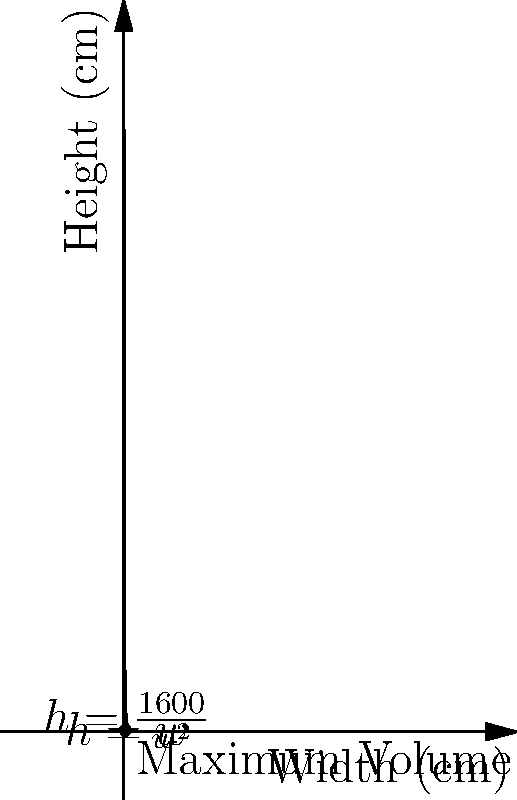As a small business owner, you want to design a new product package that maximizes volume while minimizing material costs. The package is a rectangular prism with a square base. The total surface area of the package must be 1600 cm². What dimensions should you choose to maximize the volume of the package? Let's approach this step-by-step:

1) Let $w$ be the width of the square base and $h$ be the height of the prism.

2) The surface area of the prism is given by:
   $SA = 2w^2 + 4wh = 1600$

3) Solving for $h$:
   $h = \frac{1600 - 2w^2}{4w} = \frac{800}{2w} - \frac{w}{2} = \frac{1600 - w^3}{4w}$

4) The volume of the prism is:
   $V = w^2h = w^2(\frac{1600 - w^3}{4w}) = \frac{1600w - w^4}{4}$

5) To find the maximum volume, we differentiate $V$ with respect to $w$ and set it to zero:
   $\frac{dV}{dw} = \frac{1600 - 4w^3}{4} = 0$

6) Solving this equation:
   $1600 - 4w^3 = 0$
   $4w^3 = 1600$
   $w^3 = 400$
   $w = \sqrt[3]{400} = 4\sqrt[3]{4} \approx 6.35$ cm

7) The height $h$ will be equal to the width $w$ at the maximum volume point.

8) Therefore, the dimensions for maximum volume are:
   Width = Length = Height ≈ 6.35 cm
Answer: Width = Length = Height ≈ 6.35 cm 